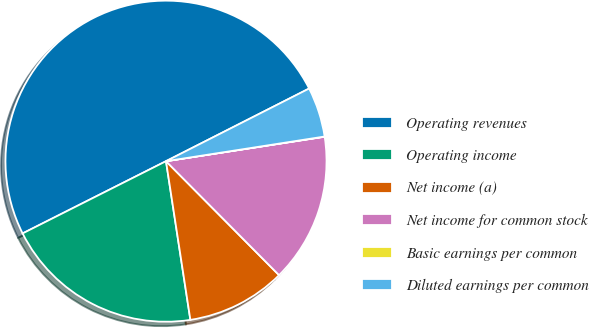<chart> <loc_0><loc_0><loc_500><loc_500><pie_chart><fcel>Operating revenues<fcel>Operating income<fcel>Net income (a)<fcel>Net income for common stock<fcel>Basic earnings per common<fcel>Diluted earnings per common<nl><fcel>49.95%<fcel>20.0%<fcel>10.01%<fcel>15.0%<fcel>0.02%<fcel>5.02%<nl></chart> 